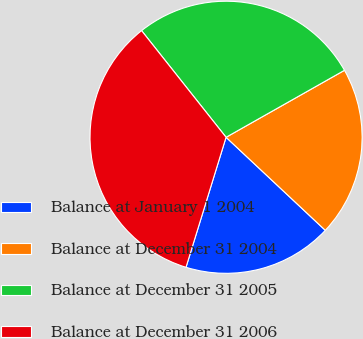Convert chart. <chart><loc_0><loc_0><loc_500><loc_500><pie_chart><fcel>Balance at January 1 2004<fcel>Balance at December 31 2004<fcel>Balance at December 31 2005<fcel>Balance at December 31 2006<nl><fcel>17.77%<fcel>20.18%<fcel>27.47%<fcel>34.58%<nl></chart> 